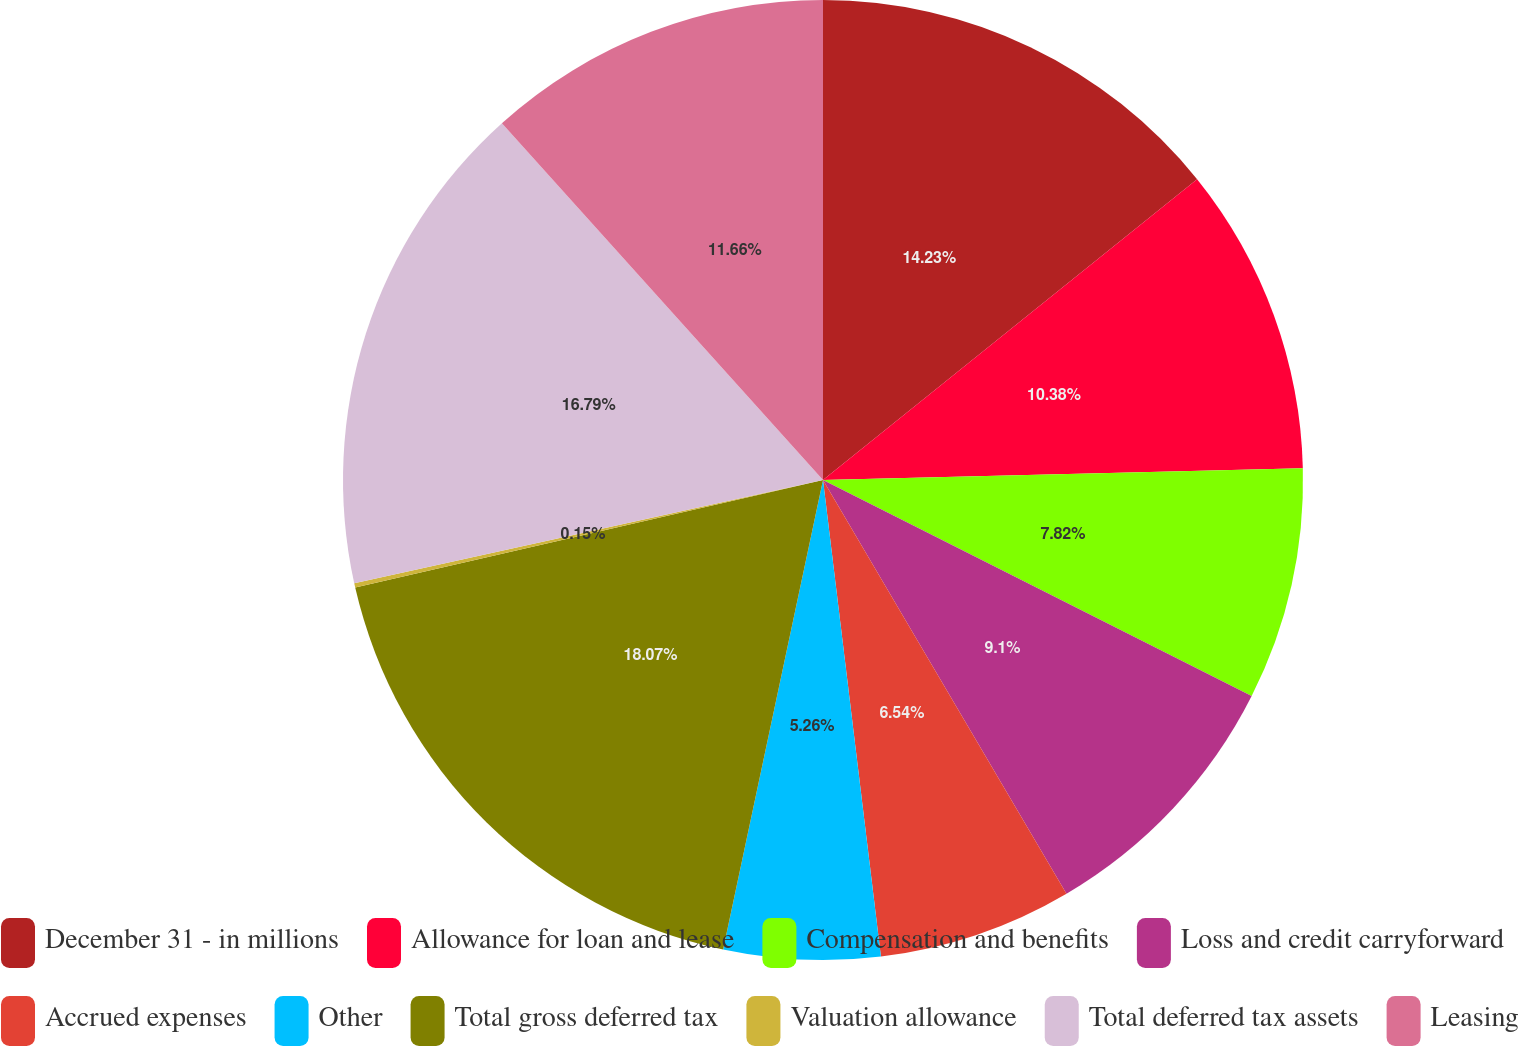<chart> <loc_0><loc_0><loc_500><loc_500><pie_chart><fcel>December 31 - in millions<fcel>Allowance for loan and lease<fcel>Compensation and benefits<fcel>Loss and credit carryforward<fcel>Accrued expenses<fcel>Other<fcel>Total gross deferred tax<fcel>Valuation allowance<fcel>Total deferred tax assets<fcel>Leasing<nl><fcel>14.22%<fcel>10.38%<fcel>7.82%<fcel>9.1%<fcel>6.54%<fcel>5.26%<fcel>18.06%<fcel>0.15%<fcel>16.78%<fcel>11.66%<nl></chart> 